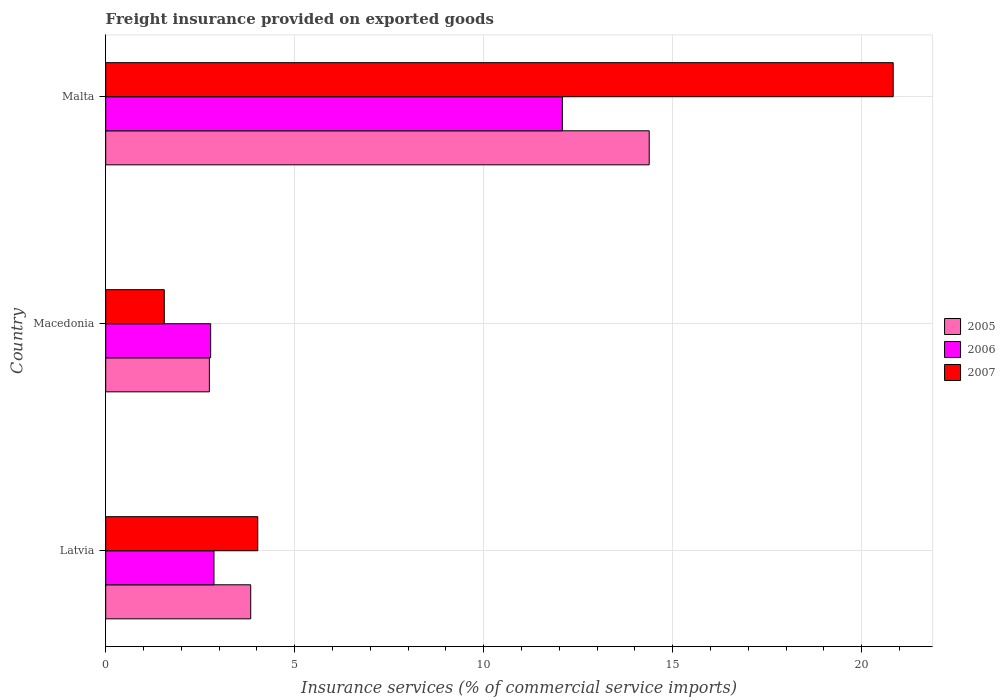How many groups of bars are there?
Make the answer very short. 3. Are the number of bars on each tick of the Y-axis equal?
Offer a very short reply. Yes. How many bars are there on the 2nd tick from the bottom?
Keep it short and to the point. 3. What is the label of the 3rd group of bars from the top?
Provide a succinct answer. Latvia. In how many cases, is the number of bars for a given country not equal to the number of legend labels?
Provide a succinct answer. 0. What is the freight insurance provided on exported goods in 2005 in Latvia?
Your answer should be compact. 3.84. Across all countries, what is the maximum freight insurance provided on exported goods in 2005?
Provide a succinct answer. 14.38. Across all countries, what is the minimum freight insurance provided on exported goods in 2006?
Your response must be concise. 2.78. In which country was the freight insurance provided on exported goods in 2007 maximum?
Offer a very short reply. Malta. In which country was the freight insurance provided on exported goods in 2006 minimum?
Your answer should be compact. Macedonia. What is the total freight insurance provided on exported goods in 2006 in the graph?
Your answer should be compact. 17.72. What is the difference between the freight insurance provided on exported goods in 2005 in Latvia and that in Macedonia?
Provide a short and direct response. 1.09. What is the difference between the freight insurance provided on exported goods in 2007 in Malta and the freight insurance provided on exported goods in 2006 in Macedonia?
Make the answer very short. 18.06. What is the average freight insurance provided on exported goods in 2006 per country?
Give a very brief answer. 5.91. What is the difference between the freight insurance provided on exported goods in 2007 and freight insurance provided on exported goods in 2006 in Latvia?
Keep it short and to the point. 1.16. What is the ratio of the freight insurance provided on exported goods in 2006 in Macedonia to that in Malta?
Offer a terse response. 0.23. What is the difference between the highest and the second highest freight insurance provided on exported goods in 2005?
Offer a very short reply. 10.54. What is the difference between the highest and the lowest freight insurance provided on exported goods in 2006?
Provide a succinct answer. 9.3. In how many countries, is the freight insurance provided on exported goods in 2005 greater than the average freight insurance provided on exported goods in 2005 taken over all countries?
Your answer should be compact. 1. What does the 3rd bar from the top in Malta represents?
Provide a short and direct response. 2005. What does the 2nd bar from the bottom in Latvia represents?
Your answer should be compact. 2006. How many bars are there?
Keep it short and to the point. 9. How many countries are there in the graph?
Your response must be concise. 3. Are the values on the major ticks of X-axis written in scientific E-notation?
Provide a succinct answer. No. Where does the legend appear in the graph?
Keep it short and to the point. Center right. How many legend labels are there?
Your response must be concise. 3. How are the legend labels stacked?
Keep it short and to the point. Vertical. What is the title of the graph?
Give a very brief answer. Freight insurance provided on exported goods. Does "1960" appear as one of the legend labels in the graph?
Your answer should be very brief. No. What is the label or title of the X-axis?
Offer a very short reply. Insurance services (% of commercial service imports). What is the Insurance services (% of commercial service imports) in 2005 in Latvia?
Give a very brief answer. 3.84. What is the Insurance services (% of commercial service imports) in 2006 in Latvia?
Provide a succinct answer. 2.86. What is the Insurance services (% of commercial service imports) of 2007 in Latvia?
Your answer should be compact. 4.02. What is the Insurance services (% of commercial service imports) in 2005 in Macedonia?
Offer a terse response. 2.74. What is the Insurance services (% of commercial service imports) in 2006 in Macedonia?
Offer a terse response. 2.78. What is the Insurance services (% of commercial service imports) in 2007 in Macedonia?
Make the answer very short. 1.55. What is the Insurance services (% of commercial service imports) of 2005 in Malta?
Ensure brevity in your answer.  14.38. What is the Insurance services (% of commercial service imports) in 2006 in Malta?
Give a very brief answer. 12.08. What is the Insurance services (% of commercial service imports) of 2007 in Malta?
Your answer should be very brief. 20.83. Across all countries, what is the maximum Insurance services (% of commercial service imports) of 2005?
Offer a terse response. 14.38. Across all countries, what is the maximum Insurance services (% of commercial service imports) in 2006?
Keep it short and to the point. 12.08. Across all countries, what is the maximum Insurance services (% of commercial service imports) in 2007?
Offer a terse response. 20.83. Across all countries, what is the minimum Insurance services (% of commercial service imports) in 2005?
Provide a succinct answer. 2.74. Across all countries, what is the minimum Insurance services (% of commercial service imports) of 2006?
Offer a very short reply. 2.78. Across all countries, what is the minimum Insurance services (% of commercial service imports) of 2007?
Your answer should be very brief. 1.55. What is the total Insurance services (% of commercial service imports) of 2005 in the graph?
Your response must be concise. 20.96. What is the total Insurance services (% of commercial service imports) in 2006 in the graph?
Your answer should be very brief. 17.72. What is the total Insurance services (% of commercial service imports) of 2007 in the graph?
Your response must be concise. 26.4. What is the difference between the Insurance services (% of commercial service imports) of 2005 in Latvia and that in Macedonia?
Make the answer very short. 1.09. What is the difference between the Insurance services (% of commercial service imports) in 2006 in Latvia and that in Macedonia?
Provide a short and direct response. 0.09. What is the difference between the Insurance services (% of commercial service imports) in 2007 in Latvia and that in Macedonia?
Make the answer very short. 2.47. What is the difference between the Insurance services (% of commercial service imports) of 2005 in Latvia and that in Malta?
Offer a terse response. -10.54. What is the difference between the Insurance services (% of commercial service imports) in 2006 in Latvia and that in Malta?
Ensure brevity in your answer.  -9.22. What is the difference between the Insurance services (% of commercial service imports) in 2007 in Latvia and that in Malta?
Make the answer very short. -16.81. What is the difference between the Insurance services (% of commercial service imports) in 2005 in Macedonia and that in Malta?
Your response must be concise. -11.64. What is the difference between the Insurance services (% of commercial service imports) in 2006 in Macedonia and that in Malta?
Offer a very short reply. -9.3. What is the difference between the Insurance services (% of commercial service imports) of 2007 in Macedonia and that in Malta?
Your answer should be compact. -19.28. What is the difference between the Insurance services (% of commercial service imports) of 2005 in Latvia and the Insurance services (% of commercial service imports) of 2006 in Macedonia?
Your response must be concise. 1.06. What is the difference between the Insurance services (% of commercial service imports) of 2005 in Latvia and the Insurance services (% of commercial service imports) of 2007 in Macedonia?
Give a very brief answer. 2.29. What is the difference between the Insurance services (% of commercial service imports) of 2006 in Latvia and the Insurance services (% of commercial service imports) of 2007 in Macedonia?
Your response must be concise. 1.31. What is the difference between the Insurance services (% of commercial service imports) of 2005 in Latvia and the Insurance services (% of commercial service imports) of 2006 in Malta?
Keep it short and to the point. -8.24. What is the difference between the Insurance services (% of commercial service imports) of 2005 in Latvia and the Insurance services (% of commercial service imports) of 2007 in Malta?
Your response must be concise. -17. What is the difference between the Insurance services (% of commercial service imports) of 2006 in Latvia and the Insurance services (% of commercial service imports) of 2007 in Malta?
Ensure brevity in your answer.  -17.97. What is the difference between the Insurance services (% of commercial service imports) of 2005 in Macedonia and the Insurance services (% of commercial service imports) of 2006 in Malta?
Make the answer very short. -9.34. What is the difference between the Insurance services (% of commercial service imports) of 2005 in Macedonia and the Insurance services (% of commercial service imports) of 2007 in Malta?
Offer a very short reply. -18.09. What is the difference between the Insurance services (% of commercial service imports) of 2006 in Macedonia and the Insurance services (% of commercial service imports) of 2007 in Malta?
Offer a very short reply. -18.05. What is the average Insurance services (% of commercial service imports) in 2005 per country?
Your answer should be very brief. 6.99. What is the average Insurance services (% of commercial service imports) of 2006 per country?
Offer a terse response. 5.91. What is the average Insurance services (% of commercial service imports) in 2007 per country?
Offer a very short reply. 8.8. What is the difference between the Insurance services (% of commercial service imports) in 2005 and Insurance services (% of commercial service imports) in 2006 in Latvia?
Offer a terse response. 0.97. What is the difference between the Insurance services (% of commercial service imports) in 2005 and Insurance services (% of commercial service imports) in 2007 in Latvia?
Give a very brief answer. -0.19. What is the difference between the Insurance services (% of commercial service imports) of 2006 and Insurance services (% of commercial service imports) of 2007 in Latvia?
Your answer should be compact. -1.16. What is the difference between the Insurance services (% of commercial service imports) in 2005 and Insurance services (% of commercial service imports) in 2006 in Macedonia?
Keep it short and to the point. -0.03. What is the difference between the Insurance services (% of commercial service imports) of 2005 and Insurance services (% of commercial service imports) of 2007 in Macedonia?
Offer a very short reply. 1.19. What is the difference between the Insurance services (% of commercial service imports) of 2006 and Insurance services (% of commercial service imports) of 2007 in Macedonia?
Offer a very short reply. 1.23. What is the difference between the Insurance services (% of commercial service imports) of 2005 and Insurance services (% of commercial service imports) of 2006 in Malta?
Your answer should be very brief. 2.3. What is the difference between the Insurance services (% of commercial service imports) in 2005 and Insurance services (% of commercial service imports) in 2007 in Malta?
Your answer should be very brief. -6.45. What is the difference between the Insurance services (% of commercial service imports) of 2006 and Insurance services (% of commercial service imports) of 2007 in Malta?
Make the answer very short. -8.75. What is the ratio of the Insurance services (% of commercial service imports) of 2005 in Latvia to that in Macedonia?
Your answer should be compact. 1.4. What is the ratio of the Insurance services (% of commercial service imports) in 2006 in Latvia to that in Macedonia?
Ensure brevity in your answer.  1.03. What is the ratio of the Insurance services (% of commercial service imports) of 2007 in Latvia to that in Macedonia?
Provide a short and direct response. 2.59. What is the ratio of the Insurance services (% of commercial service imports) in 2005 in Latvia to that in Malta?
Provide a short and direct response. 0.27. What is the ratio of the Insurance services (% of commercial service imports) in 2006 in Latvia to that in Malta?
Offer a terse response. 0.24. What is the ratio of the Insurance services (% of commercial service imports) in 2007 in Latvia to that in Malta?
Provide a short and direct response. 0.19. What is the ratio of the Insurance services (% of commercial service imports) in 2005 in Macedonia to that in Malta?
Offer a terse response. 0.19. What is the ratio of the Insurance services (% of commercial service imports) of 2006 in Macedonia to that in Malta?
Your answer should be very brief. 0.23. What is the ratio of the Insurance services (% of commercial service imports) of 2007 in Macedonia to that in Malta?
Offer a terse response. 0.07. What is the difference between the highest and the second highest Insurance services (% of commercial service imports) in 2005?
Make the answer very short. 10.54. What is the difference between the highest and the second highest Insurance services (% of commercial service imports) of 2006?
Offer a very short reply. 9.22. What is the difference between the highest and the second highest Insurance services (% of commercial service imports) of 2007?
Keep it short and to the point. 16.81. What is the difference between the highest and the lowest Insurance services (% of commercial service imports) of 2005?
Your response must be concise. 11.64. What is the difference between the highest and the lowest Insurance services (% of commercial service imports) in 2006?
Give a very brief answer. 9.3. What is the difference between the highest and the lowest Insurance services (% of commercial service imports) in 2007?
Offer a very short reply. 19.28. 